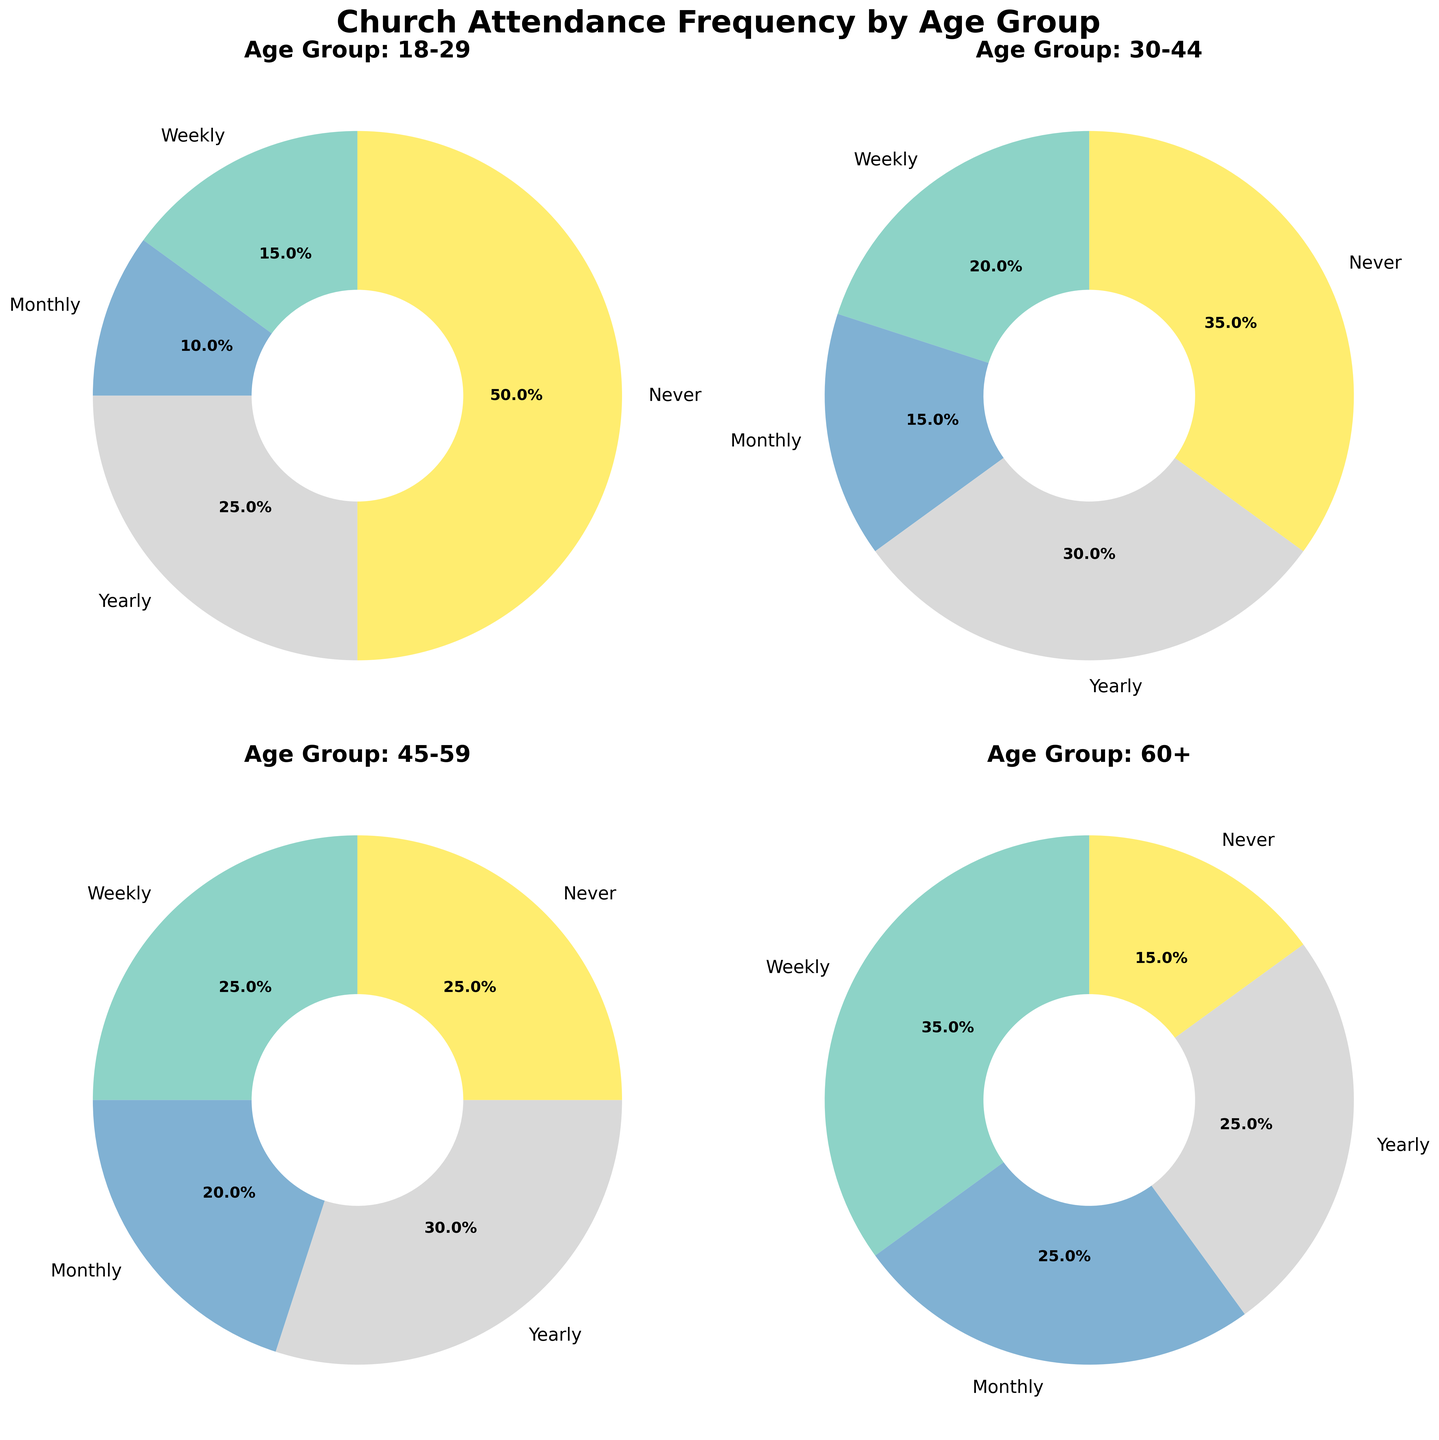What percentage of the 30-44 age group attends church yearly and never? To find this, look at the 30-44 age group's section in the chart. Add the percentages for 'Yearly' (30%) and 'Never' (35%).
Answer: 65% What age group has the highest percentage of people who never attend church? Compare the 'Never' sections across all age group pie charts. The 18-29 age group has the highest 'Never' percentage at 50%.
Answer: 18-29 Which attendance frequency category has the smallest percentage in the 60+ age group? Check the pie chart for the 60+ age group. The 'Never' category has the smallest slice, at 15%.
Answer: Never Are there more people who attend church weekly in the 45-59 age group or the 30-44 age group? Compare the 'Weekly' sections: 25% for 45-59 age group and 20% for 30-44 age group. The 45-59 group has a higher percentage.
Answer: 45-59 What is the total percentage of people in the 18-29 age group who attend church either weekly or monthly? Add the percentages for 'Weekly' (15%) and 'Monthly' (10%) for the 18-29 age group. The total is 25%.
Answer: 25% What is the difference in percentage of weekly attendance between the 18-29 age group and the 60+ age group? Subtract the 'Weekly' percentage for the 18-29 group (15%) from the 60+ group (35%). The difference is 20%.
Answer: 20% Which age group has the highest percentage of monthly attendance? Compare the 'Monthly' sections for all age groups. The 60+ age group has the highest monthly attendance at 25%.
Answer: 60+ What is the combined percentage of yearly and never attendance for the 45-59 age group? Add the 'Yearly' (30%) and 'Never' (25%) percentages for the 45-59 age group. The combined percentage is 55%.
Answer: 55% Which age group has the most evenly distributed church attendance frequency percentages? Compare the percentage distribution across frequencies in each age group. The 45-59 age group has the most even distribution with percentages of 25%, 20%, 30%, and 25%.
Answer: 45-59 